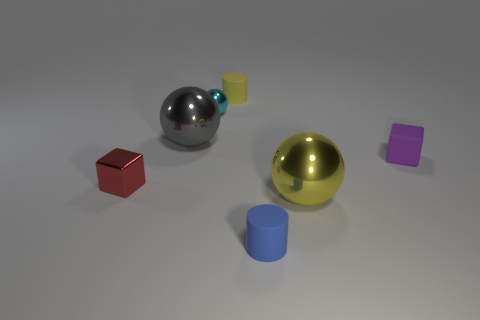There is a tiny metallic thing behind the large metal object that is on the left side of the yellow cylinder; what color is it?
Your answer should be very brief. Cyan. What is the color of the rubber block that is the same size as the blue object?
Your answer should be compact. Purple. What number of large things are either balls or purple shiny blocks?
Make the answer very short. 2. Is the number of small matte things that are behind the yellow cylinder greater than the number of tiny yellow cylinders behind the matte cube?
Keep it short and to the point. No. How many other things are the same size as the red object?
Your answer should be very brief. 4. Does the tiny cylinder to the right of the yellow matte object have the same material as the purple object?
Ensure brevity in your answer.  Yes. How many other objects are the same color as the matte block?
Offer a terse response. 0. What number of other objects are the same shape as the large yellow object?
Offer a very short reply. 2. Do the big metallic thing right of the gray thing and the big object that is behind the purple object have the same shape?
Your answer should be very brief. Yes. Are there an equal number of yellow spheres left of the large gray thing and matte cylinders in front of the blue matte object?
Make the answer very short. Yes. 